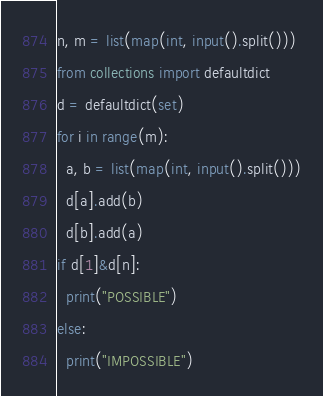Convert code to text. <code><loc_0><loc_0><loc_500><loc_500><_Python_>n, m = list(map(int, input().split()))
from collections import defaultdict
d = defaultdict(set)
for i in range(m):
  a, b = list(map(int, input().split()))
  d[a].add(b)
  d[b].add(a)
if d[1]&d[n]:
  print("POSSIBLE")
else:
  print("IMPOSSIBLE")</code> 